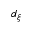Convert formula to latex. <formula><loc_0><loc_0><loc_500><loc_500>d _ { \xi }</formula> 